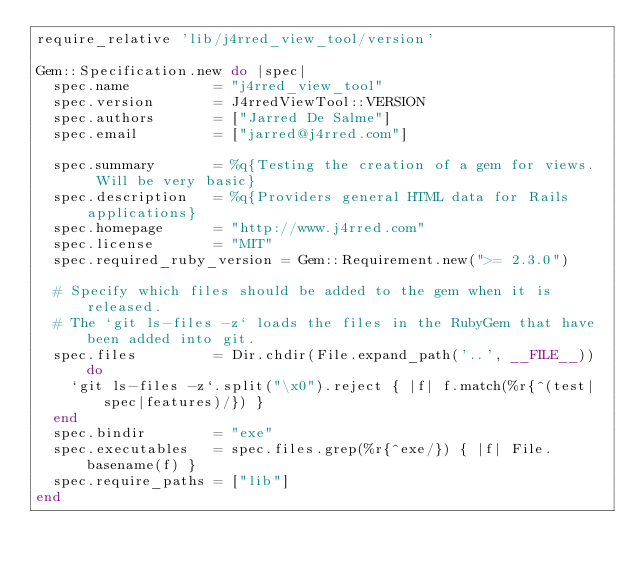Convert code to text. <code><loc_0><loc_0><loc_500><loc_500><_Ruby_>require_relative 'lib/j4rred_view_tool/version'

Gem::Specification.new do |spec|
  spec.name          = "j4rred_view_tool"
  spec.version       = J4rredViewTool::VERSION
  spec.authors       = ["Jarred De Salme"]
  spec.email         = ["jarred@j4rred.com"]

  spec.summary       = %q{Testing the creation of a gem for views.  Will be very basic}
  spec.description   = %q{Providers general HTML data for Rails applications}
  spec.homepage      = "http://www.j4rred.com"
  spec.license       = "MIT"
  spec.required_ruby_version = Gem::Requirement.new(">= 2.3.0")

  # Specify which files should be added to the gem when it is released.
  # The `git ls-files -z` loads the files in the RubyGem that have been added into git.
  spec.files         = Dir.chdir(File.expand_path('..', __FILE__)) do
    `git ls-files -z`.split("\x0").reject { |f| f.match(%r{^(test|spec|features)/}) }
  end
  spec.bindir        = "exe"
  spec.executables   = spec.files.grep(%r{^exe/}) { |f| File.basename(f) }
  spec.require_paths = ["lib"]
end
</code> 